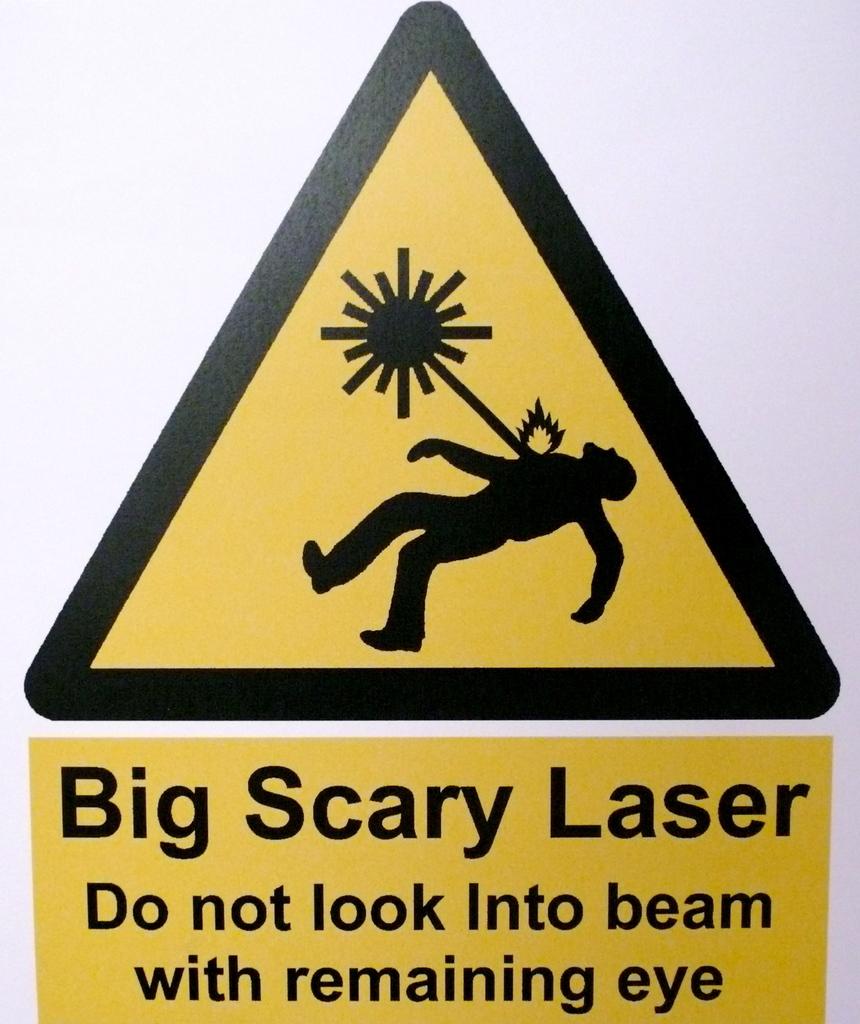Is this a laser?
Provide a succinct answer. Yes. 